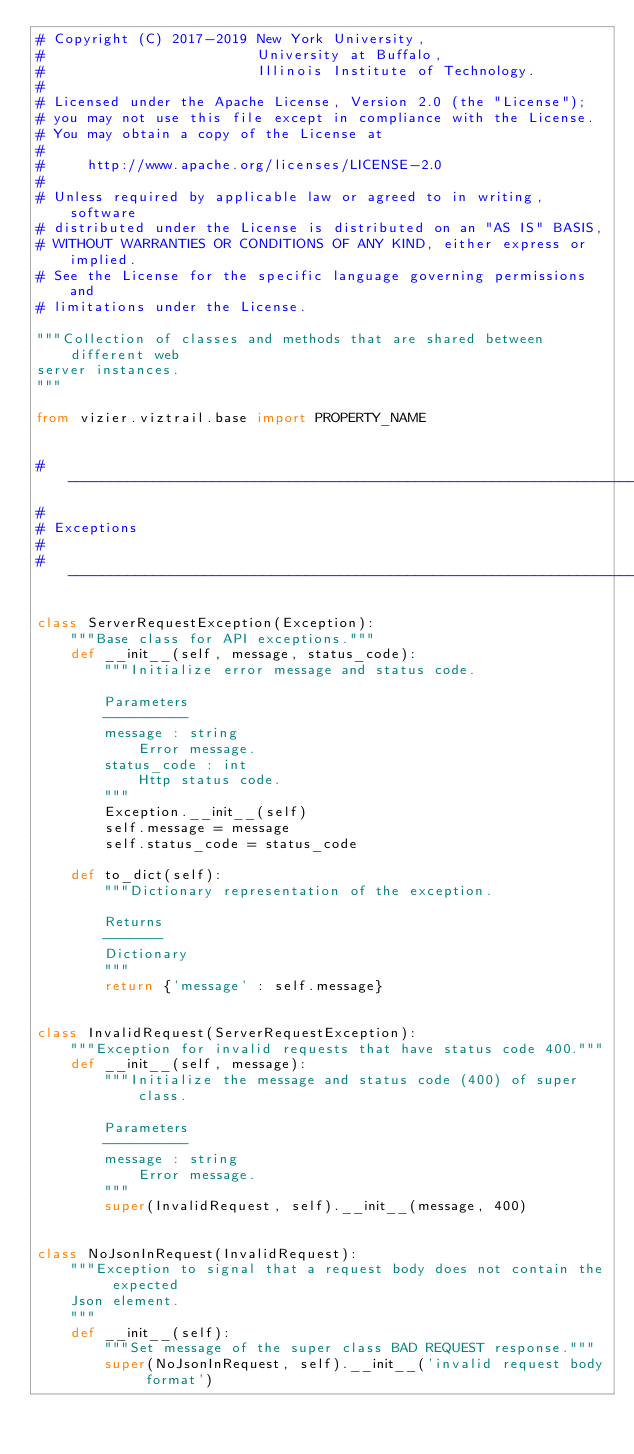<code> <loc_0><loc_0><loc_500><loc_500><_Python_># Copyright (C) 2017-2019 New York University,
#                         University at Buffalo,
#                         Illinois Institute of Technology.
#
# Licensed under the Apache License, Version 2.0 (the "License");
# you may not use this file except in compliance with the License.
# You may obtain a copy of the License at
#
#     http://www.apache.org/licenses/LICENSE-2.0
#
# Unless required by applicable law or agreed to in writing, software
# distributed under the License is distributed on an "AS IS" BASIS,
# WITHOUT WARRANTIES OR CONDITIONS OF ANY KIND, either express or implied.
# See the License for the specific language governing permissions and
# limitations under the License.

"""Collection of classes and methods that are shared between different web
server instances.
"""

from vizier.viztrail.base import PROPERTY_NAME


# ------------------------------------------------------------------------------
#
# Exceptions
#
# ------------------------------------------------------------------------------

class ServerRequestException(Exception):
    """Base class for API exceptions."""
    def __init__(self, message, status_code):
        """Initialize error message and status code.

        Parameters
        ----------
        message : string
            Error message.
        status_code : int
            Http status code.
        """
        Exception.__init__(self)
        self.message = message
        self.status_code = status_code

    def to_dict(self):
        """Dictionary representation of the exception.

        Returns
        -------
        Dictionary
        """
        return {'message' : self.message}


class InvalidRequest(ServerRequestException):
    """Exception for invalid requests that have status code 400."""
    def __init__(self, message):
        """Initialize the message and status code (400) of super class.

        Parameters
        ----------
        message : string
            Error message.
        """
        super(InvalidRequest, self).__init__(message, 400)


class NoJsonInRequest(InvalidRequest):
    """Exception to signal that a request body does not contain the expected
    Json element.
    """
    def __init__(self):
        """Set message of the super class BAD REQUEST response."""
        super(NoJsonInRequest, self).__init__('invalid request body format')

</code> 